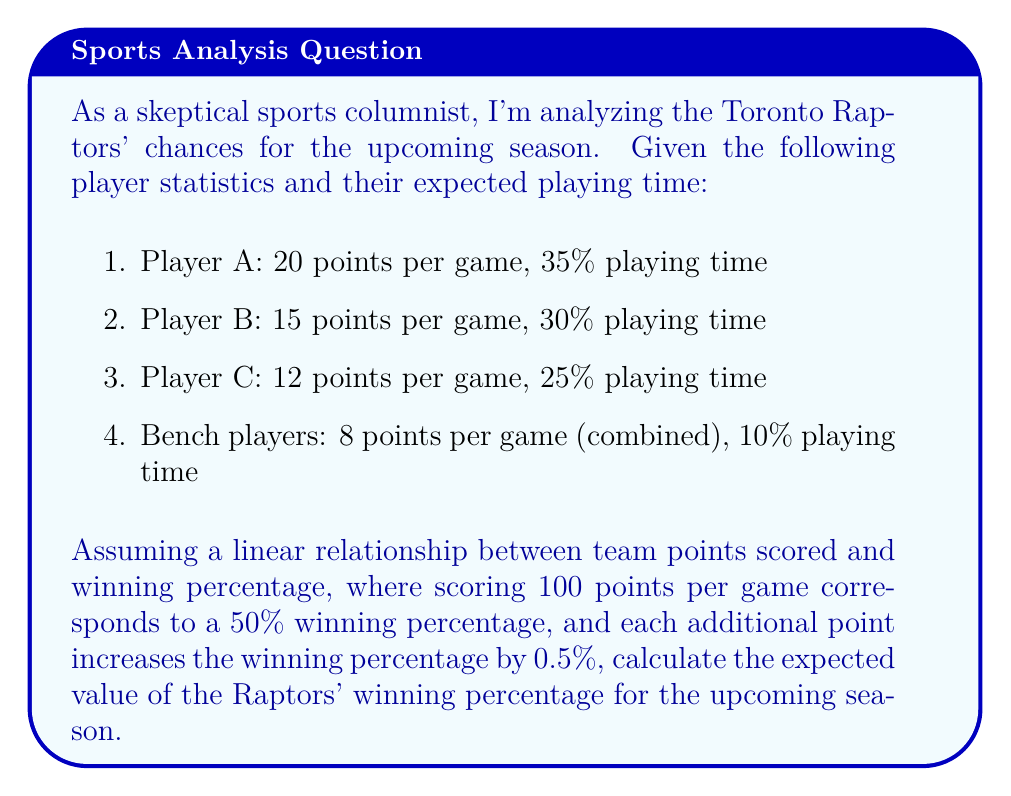Teach me how to tackle this problem. To solve this problem, we'll follow these steps:

1. Calculate the expected points per game for each player and the bench:
   Player A: $20 \times 0.35 = 7$ points
   Player B: $15 \times 0.30 = 4.5$ points
   Player C: $12 \times 0.25 = 3$ points
   Bench: $8 \times 0.10 = 0.8$ points

2. Sum up the total expected points per game:
   $$7 + 4.5 + 3 + 0.8 = 15.3$$ points

3. Calculate the winning percentage based on the linear relationship:
   - 100 points correspond to 50% winning percentage
   - Each additional point adds 0.5% to the winning percentage
   - The team is expected to score 15.3 points above 100

   Winning percentage increase: $15.3 \times 0.5\% = 7.65\%$

4. Add this increase to the base 50% winning percentage:
   $$50\% + 7.65\% = 57.65\%$$

Therefore, the expected value of the Raptors' winning percentage is 57.65%.
Answer: 57.65% 